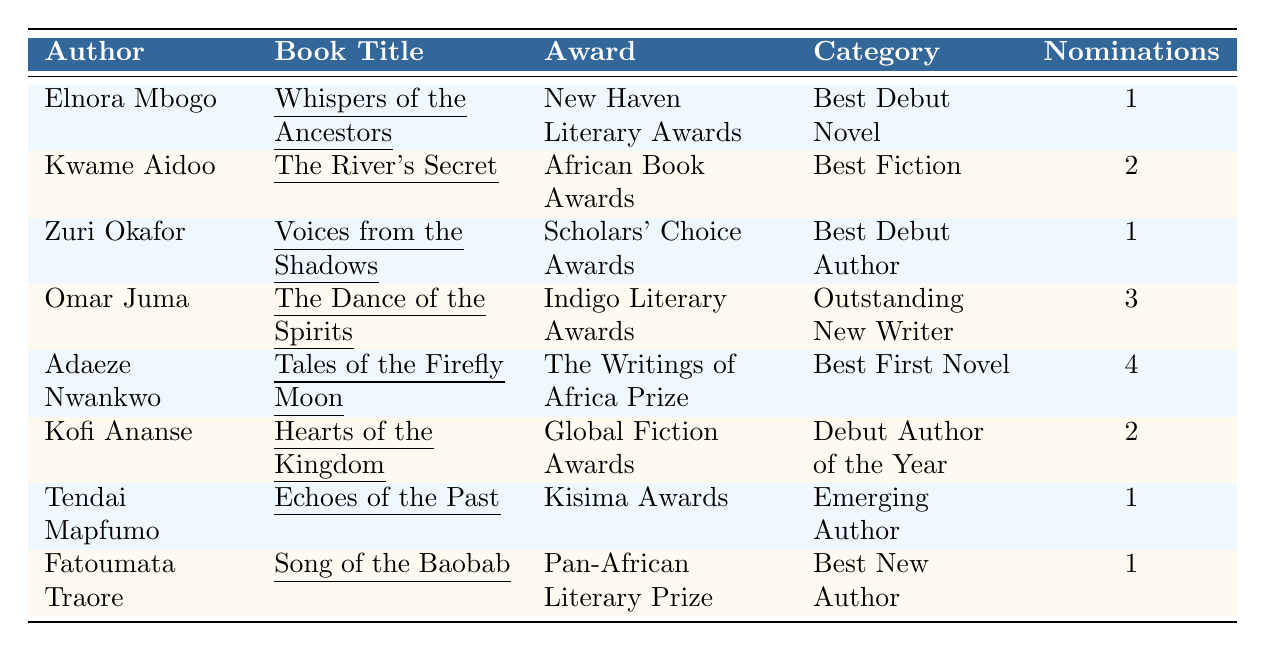What is the title of the book by Elnora Mbogo? Elnora Mbogo's book title is located in the second column of the first row of the table. The text under the "Book Title" column for Elnora Mbogo shows "Whispers of the Ancestors."
Answer: Whispers of the Ancestors Who won the award for Best First Novel? To find who won the Best First Novel, I look at the "Category" column for that specific entry. The author Adaeze Nwankwo is in the row where "Best First Novel" is listed, so Adaeze Nwankwo won this award.
Answer: Adaeze Nwankwo How many nominations did Omar Juma receive? The number of nominations for Omar Juma is found in the fifth column of the table. In the row corresponding to Omar Juma, the number of nominations is 3.
Answer: 3 Which author received the most nominations? To determine which author received the most nominations, I compare the "Nominations" column values. Adaeze Nwankwo has the highest at 4 nominations.
Answer: Adaeze Nwankwo Is it true that Fatoumata Traore received more than 1 nomination? To answer this, I check the nominations value for Fatoumata Traore in the row associated with her name. The "Nominations" value is 1, which is not more than 1. Therefore, the statement is false.
Answer: No Which author is associated with the Indigo Literary Awards? I look for the "Award" column in the table to find the entry named "Indigo Literary Awards." The author listed in the same row is Omar Juma.
Answer: Omar Juma What is the total number of nominations received by all authors listed? To find the total number of nominations, I add up all the values in the "Nominations" column: (1 + 2 + 1 + 3 + 4 + 2 + 1 + 1) = 15.
Answer: 15 How many authors have received exactly 1 nomination? I check the "Nominations" column and count the entries where the value is 1. Elnora Mbogo, Zuri Okafor, Tendai Mapfumo, and Fatoumata Traore each have 1 nomination, totaling 4 authors.
Answer: 4 What award did Kofi Ananse win? To find Kofi Ananse's award, I look in the "Award" column corresponding to his entry. Kofi Ananse won the "Global Fiction Awards."
Answer: Global Fiction Awards Which author and book title combination has the most nominations? I compare all authors' nominations and their respective book titles. Adaeze Nwankwo's combination has the highest nominations count of 4. So, the answer is "Adaeze Nwankwo - Tales of the Firefly Moon."
Answer: Adaeze Nwankwo - Tales of the Firefly Moon 